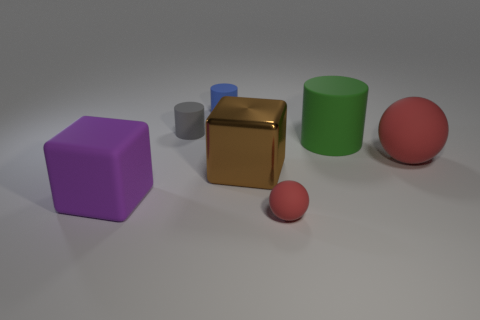There is a big object that is the same color as the tiny ball; what material is it?
Give a very brief answer. Rubber. Are the large cube that is in front of the brown cube and the large cube that is right of the large purple rubber thing made of the same material?
Keep it short and to the point. No. Is there a large object that has the same shape as the tiny blue matte thing?
Ensure brevity in your answer.  Yes. The large thing that is both in front of the large sphere and right of the blue cylinder is made of what material?
Offer a terse response. Metal. Does the cube to the left of the large brown metallic object have the same material as the brown cube?
Your response must be concise. No. What is the large brown object made of?
Your answer should be compact. Metal. There is a object that is right of the big matte cylinder; what is its size?
Your answer should be very brief. Large. How many blocks are either large green matte things or large red rubber things?
Offer a terse response. 0. What is the shape of the red thing behind the block that is right of the gray rubber cylinder?
Give a very brief answer. Sphere. What size is the ball that is left of the large object that is behind the red object that is behind the purple rubber object?
Give a very brief answer. Small. 